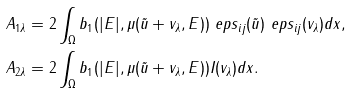<formula> <loc_0><loc_0><loc_500><loc_500>& A _ { 1 \lambda } = 2 \int _ { \Omega } b _ { 1 } ( | E | , \mu ( \tilde { u } + v _ { \lambda } , E ) ) \ e p s _ { i j } ( \tilde { u } ) \ e p s _ { i j } ( v _ { \lambda } ) d x , \\ & A _ { 2 \lambda } = 2 \int _ { \Omega } b _ { 1 } ( | E | , \mu ( \tilde { u } + v _ { \lambda } , E ) ) I ( v _ { \lambda } ) d x .</formula> 